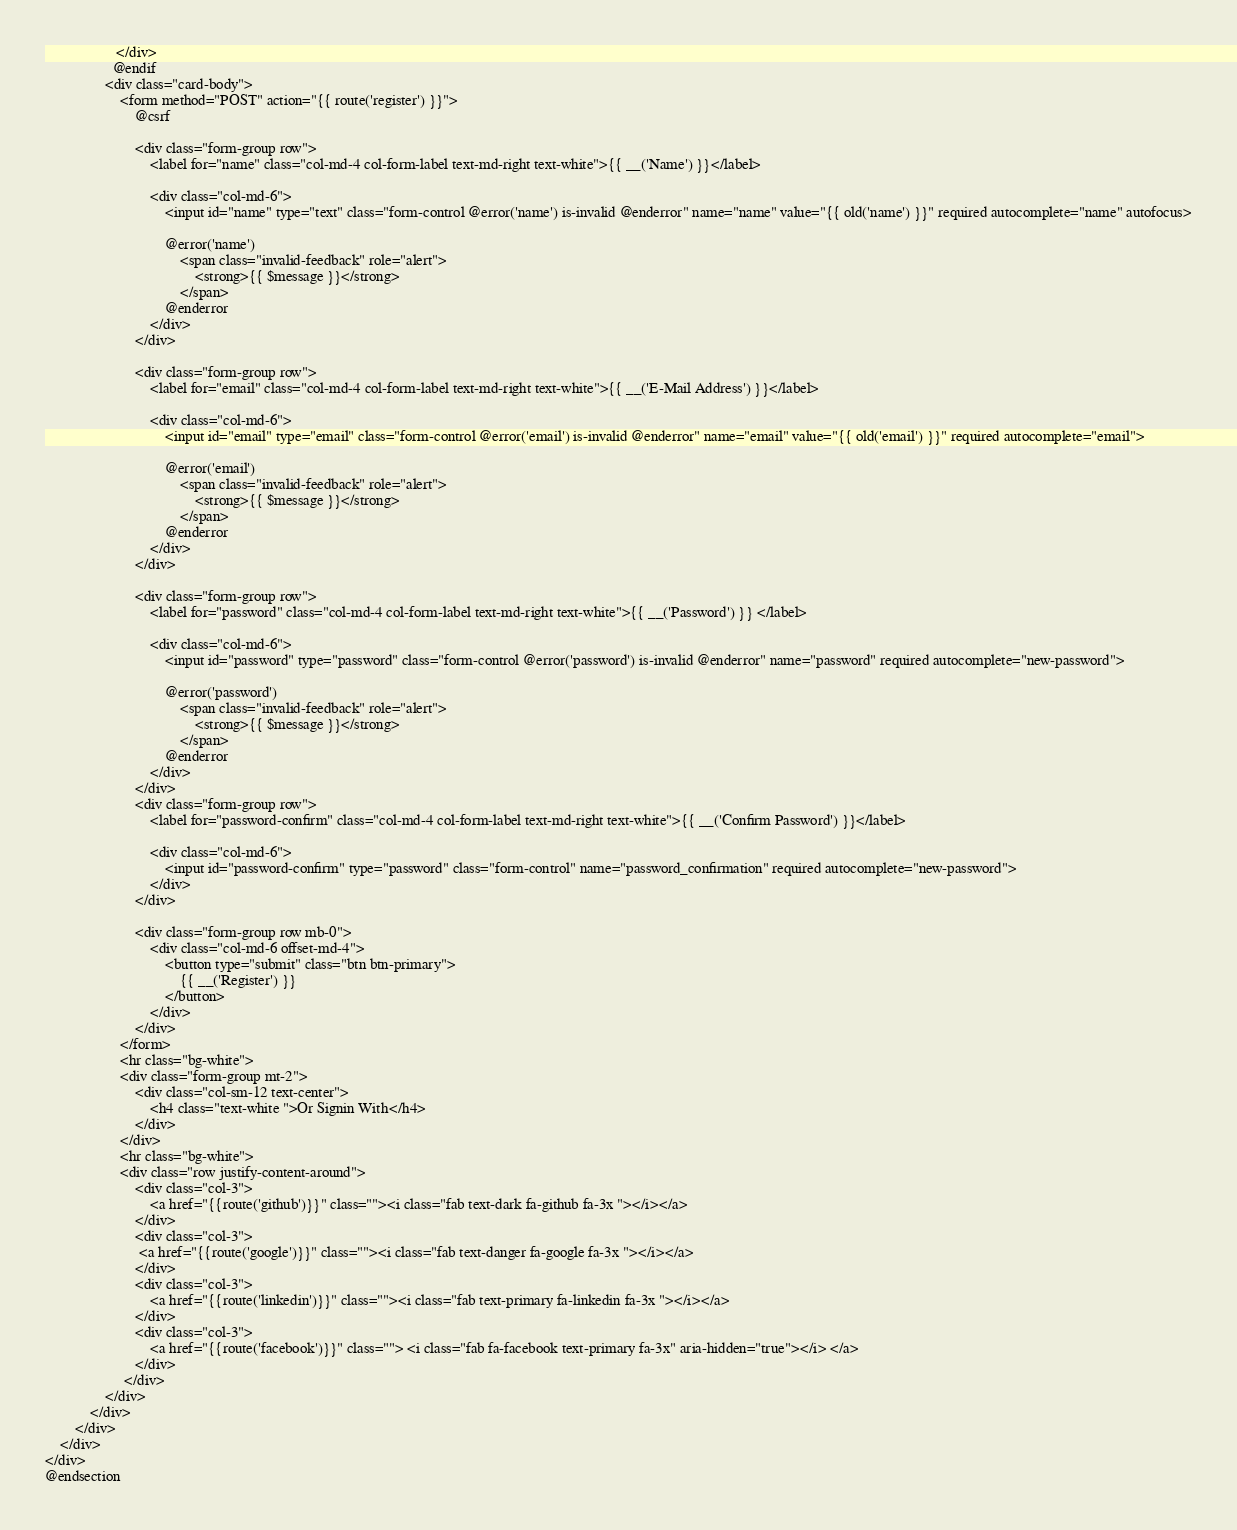<code> <loc_0><loc_0><loc_500><loc_500><_PHP_>                   </div>
                  @endif
                <div class="card-body">
                    <form method="POST" action="{{ route('register') }}">
                        @csrf

                        <div class="form-group row">
                            <label for="name" class="col-md-4 col-form-label text-md-right text-white">{{ __('Name') }}</label>

                            <div class="col-md-6">
                                <input id="name" type="text" class="form-control @error('name') is-invalid @enderror" name="name" value="{{ old('name') }}" required autocomplete="name" autofocus>

                                @error('name')
                                    <span class="invalid-feedback" role="alert">
                                        <strong>{{ $message }}</strong>
                                    </span>
                                @enderror
                            </div>
                        </div>

                        <div class="form-group row">
                            <label for="email" class="col-md-4 col-form-label text-md-right text-white">{{ __('E-Mail Address') }}</label>

                            <div class="col-md-6">
                                <input id="email" type="email" class="form-control @error('email') is-invalid @enderror" name="email" value="{{ old('email') }}" required autocomplete="email">

                                @error('email')
                                    <span class="invalid-feedback" role="alert">
                                        <strong>{{ $message }}</strong>
                                    </span>
                                @enderror
                            </div>
                        </div>

                        <div class="form-group row">
                            <label for="password" class="col-md-4 col-form-label text-md-right text-white">{{ __('Password') }} </label>

                            <div class="col-md-6">
                                <input id="password" type="password" class="form-control @error('password') is-invalid @enderror" name="password" required autocomplete="new-password">

                                @error('password')
                                    <span class="invalid-feedback" role="alert">
                                        <strong>{{ $message }}</strong>
                                    </span>
                                @enderror
                            </div>
                        </div>
                        <div class="form-group row">
                            <label for="password-confirm" class="col-md-4 col-form-label text-md-right text-white">{{ __('Confirm Password') }}</label>

                            <div class="col-md-6">
                                <input id="password-confirm" type="password" class="form-control" name="password_confirmation" required autocomplete="new-password">
                            </div>
                        </div>

                        <div class="form-group row mb-0">
                            <div class="col-md-6 offset-md-4">
                                <button type="submit" class="btn btn-primary">
                                    {{ __('Register') }}
                                </button>
                            </div>
                        </div>
                    </form>
                    <hr class="bg-white">
                    <div class="form-group mt-2">
                        <div class="col-sm-12 text-center">
                            <h4 class="text-white ">Or Signin With</h4>
                        </div>
                    </div>
                    <hr class="bg-white">
                    <div class="row justify-content-around">
                        <div class="col-3">
                            <a href="{{route('github')}}" class=""><i class="fab text-dark fa-github fa-3x "></i></a>
                        </div>
                        <div class="col-3">
                         <a href="{{route('google')}}" class=""><i class="fab text-danger fa-google fa-3x "></i></a>
                        </div>
                        <div class="col-3">
                            <a href="{{route('linkedin')}}" class=""><i class="fab text-primary fa-linkedin fa-3x "></i></a>
                        </div>
                        <div class="col-3">
                            <a href="{{route('facebook')}}" class=""> <i class="fab fa-facebook text-primary fa-3x" aria-hidden="true"></i> </a>
                        </div>
                     </div>
                </div>
            </div>
        </div>
    </div>
</div>
@endsection
</code> 